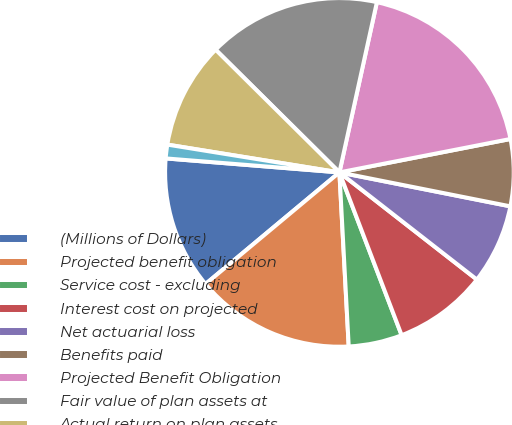Convert chart to OTSL. <chart><loc_0><loc_0><loc_500><loc_500><pie_chart><fcel>(Millions of Dollars)<fcel>Projected benefit obligation<fcel>Service cost - excluding<fcel>Interest cost on projected<fcel>Net actuarial loss<fcel>Benefits paid<fcel>Projected Benefit Obligation<fcel>Fair value of plan assets at<fcel>Actual return on plan assets<fcel>Employer contributions<nl><fcel>12.34%<fcel>14.79%<fcel>4.96%<fcel>8.65%<fcel>7.42%<fcel>6.19%<fcel>18.48%<fcel>16.02%<fcel>9.88%<fcel>1.27%<nl></chart> 